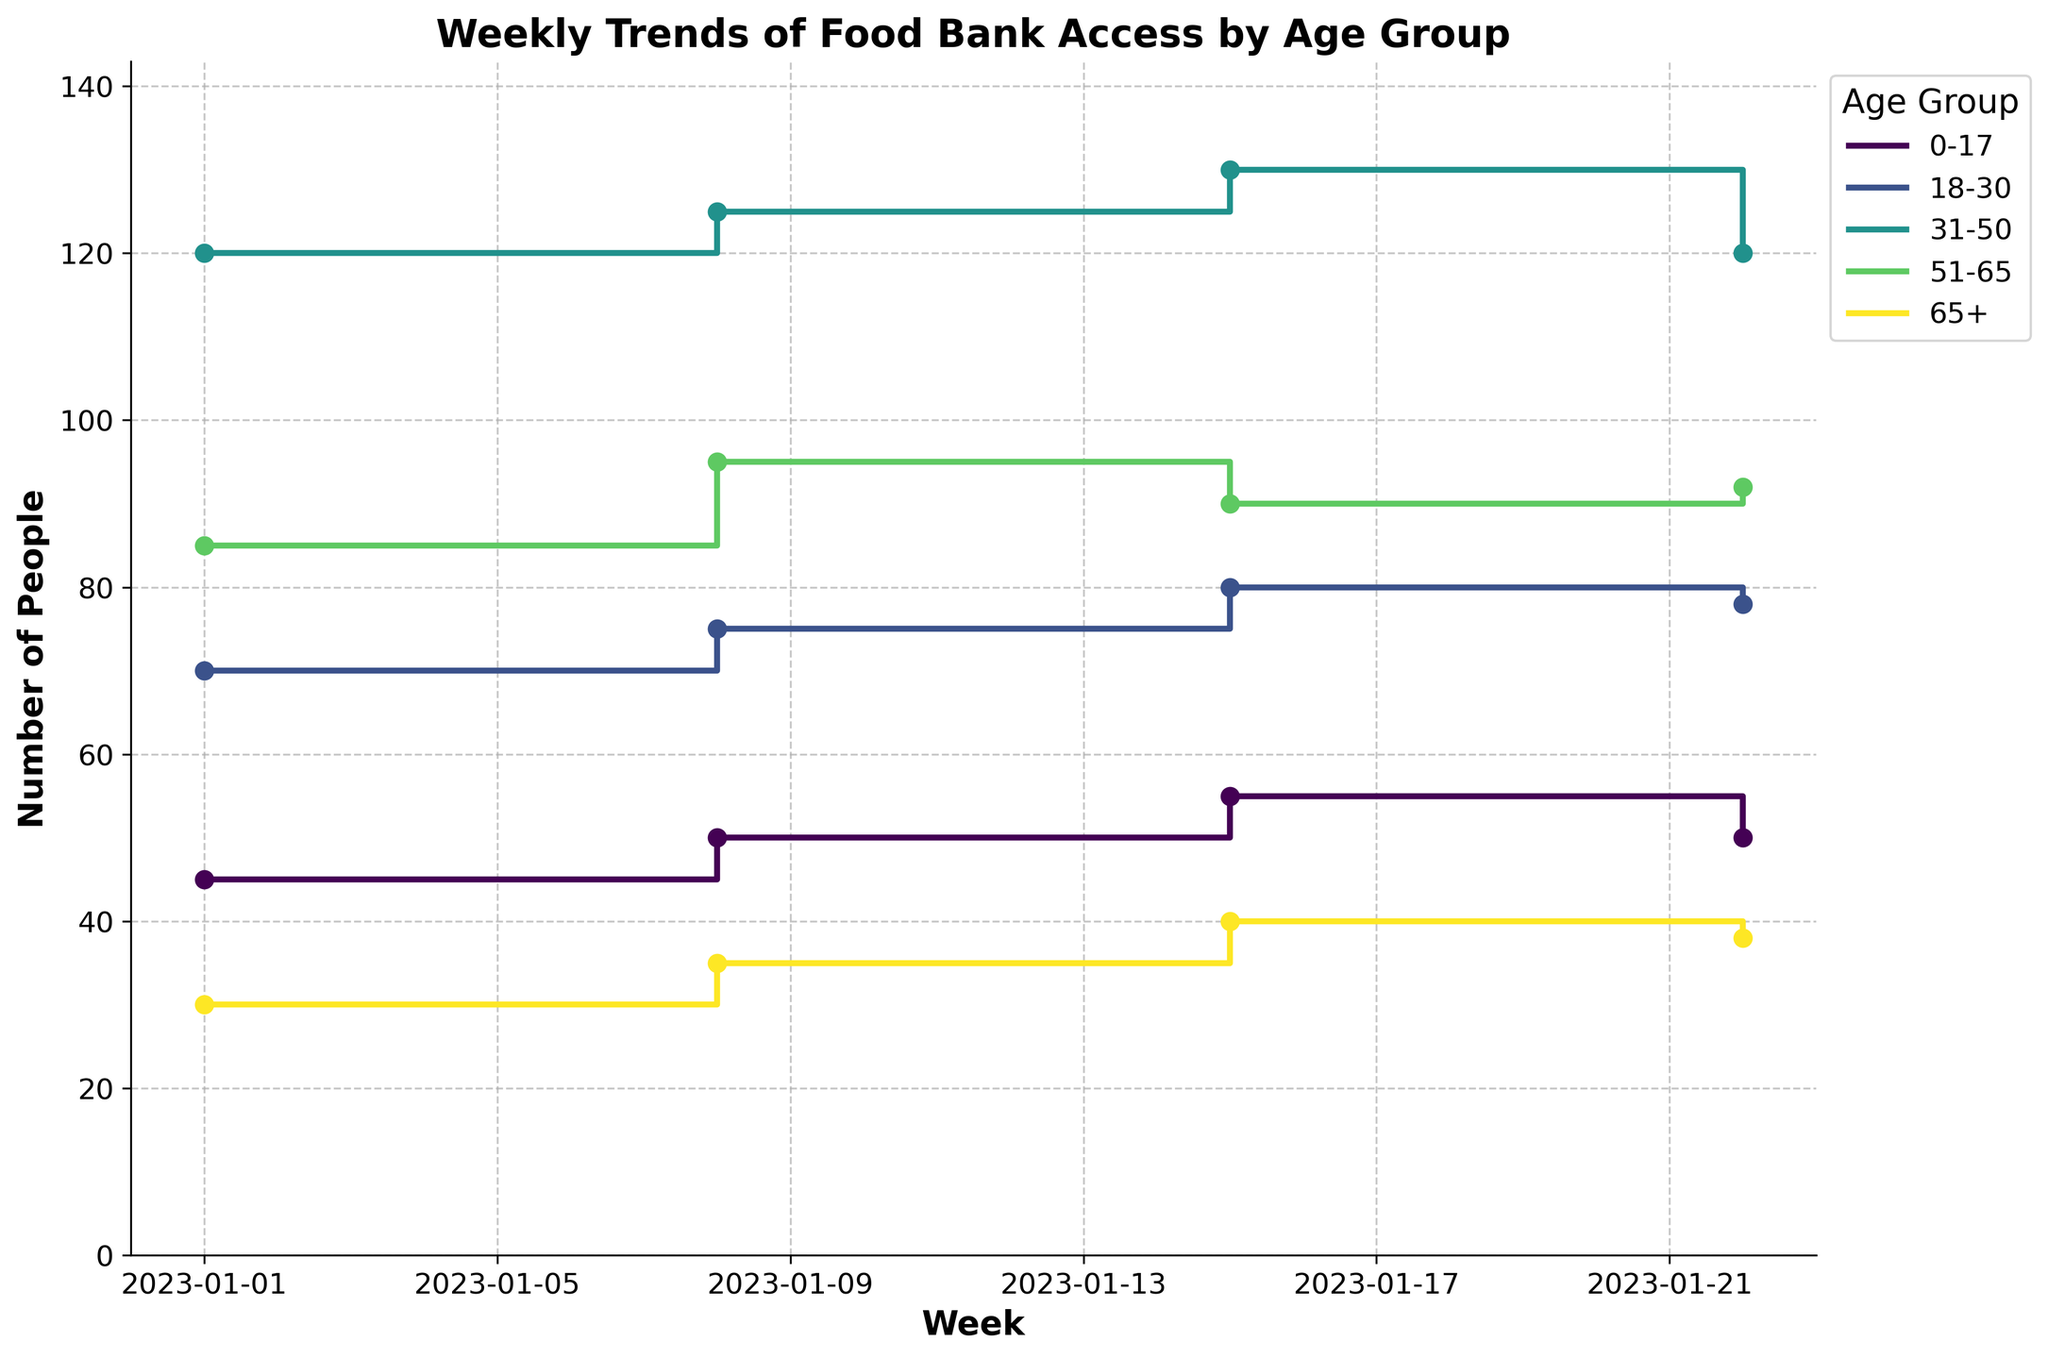What's the title of the plot? The title of the plot is displayed prominently at the top of the figure. It states the overall subject of the data being visualized.
Answer: Weekly Trends of Food Bank Access by Age Group Which age group has the highest total number of people accessing food banks in the third week? To determine which age group has the highest number of people in the third week, look at the points along the stair plots corresponding to the date 2023-01-15. Find the point with the highest y-value (number of people).
Answer: 31-50 How does the trend for the 0-17 age group change over the weeks? Observe the step plots for the 0-17 age group over the weeks. It starts at 45, then increases steadily to 55, before dropping to 50 in the final week.
Answer: Increases and then decreases What is the difference in the number of people between the 18-30 and 51-65 age groups in the first week? Find the number of people accessing food banks for the 18-30 and 51-65 age groups in the first week (2023-01-01), then calculate the difference: 70 - 85 = -15.
Answer: -15 Which age group shows a decline in the number of people from the second to the third week? Look at each age group's trend from the second week (2023-01-08) to the third (2023-01-15). Identify the group where the number of people decreases.
Answer: 51-65 What is the total number of people accessing food banks on the second week? Sum up the number of people for all age groups on the second week (2023-01-08): 50 (0-17) + 75 (18-30) + 125 (31-50) + 95 (51-65) + 35 (65+).
Answer: 380 Which age group experiences the highest variance in the number of people over the weeks? Assess how the number of people fluctuates for each age group across weeks. The 31-50 group consistently has high numbers but varies the least, while others have noticeable variations.
Answer: 31-50 What is the average number of people in the 65+ age group across all weeks? To compute the average, sum the number of people in the 65+ age group for all weeks, then divide by the number of weeks: (30 + 35 + 40 + 38) / 4 = 35.75.
Answer: 35.75 Which two age groups are closest in their total number of people accessing food banks over four weeks? Calculate the total number of people accessing food banks over all weeks for each age group, then find the two groups with the smallest difference: compare sums for each group over four weeks.
Answer: 18-30 and 51-65 